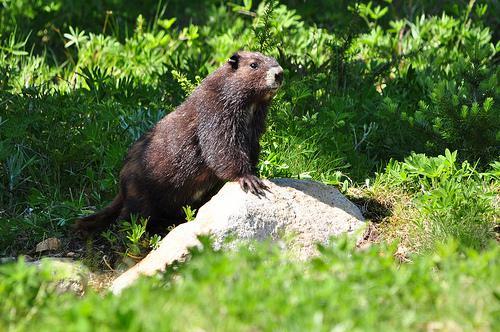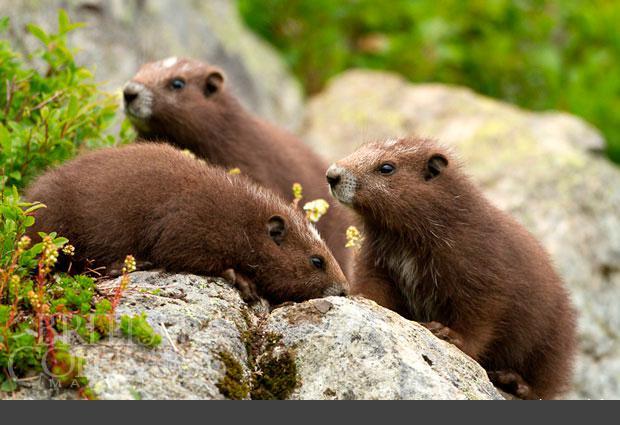The first image is the image on the left, the second image is the image on the right. Considering the images on both sides, is "We've got three groundhogs here." valid? Answer yes or no. No. The first image is the image on the left, the second image is the image on the right. For the images displayed, is the sentence "There are exactly three marmots." factually correct? Answer yes or no. No. 